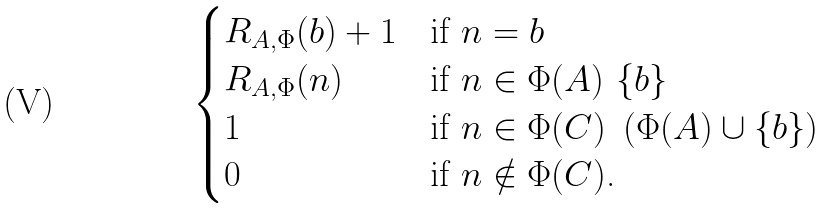<formula> <loc_0><loc_0><loc_500><loc_500>\begin{cases} R _ { A , { \Phi } } ( b ) + 1 & \text {if $n = b$} \\ R _ { A , { \Phi } } ( n ) & \text {if $n\in \Phi(A)\ \{b\}$} \\ 1 & \text {if $n\in \Phi(C)\ \left( \Phi(A) \cup \{b\} \right)$} \\ 0 & \text {if $n\notin \Phi(C)$.} \end{cases}</formula> 